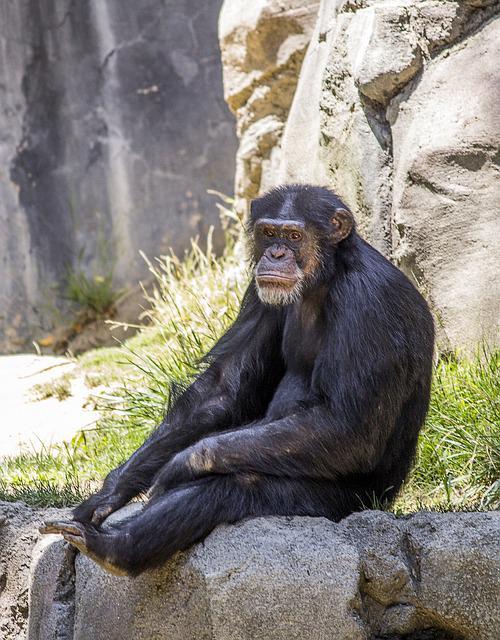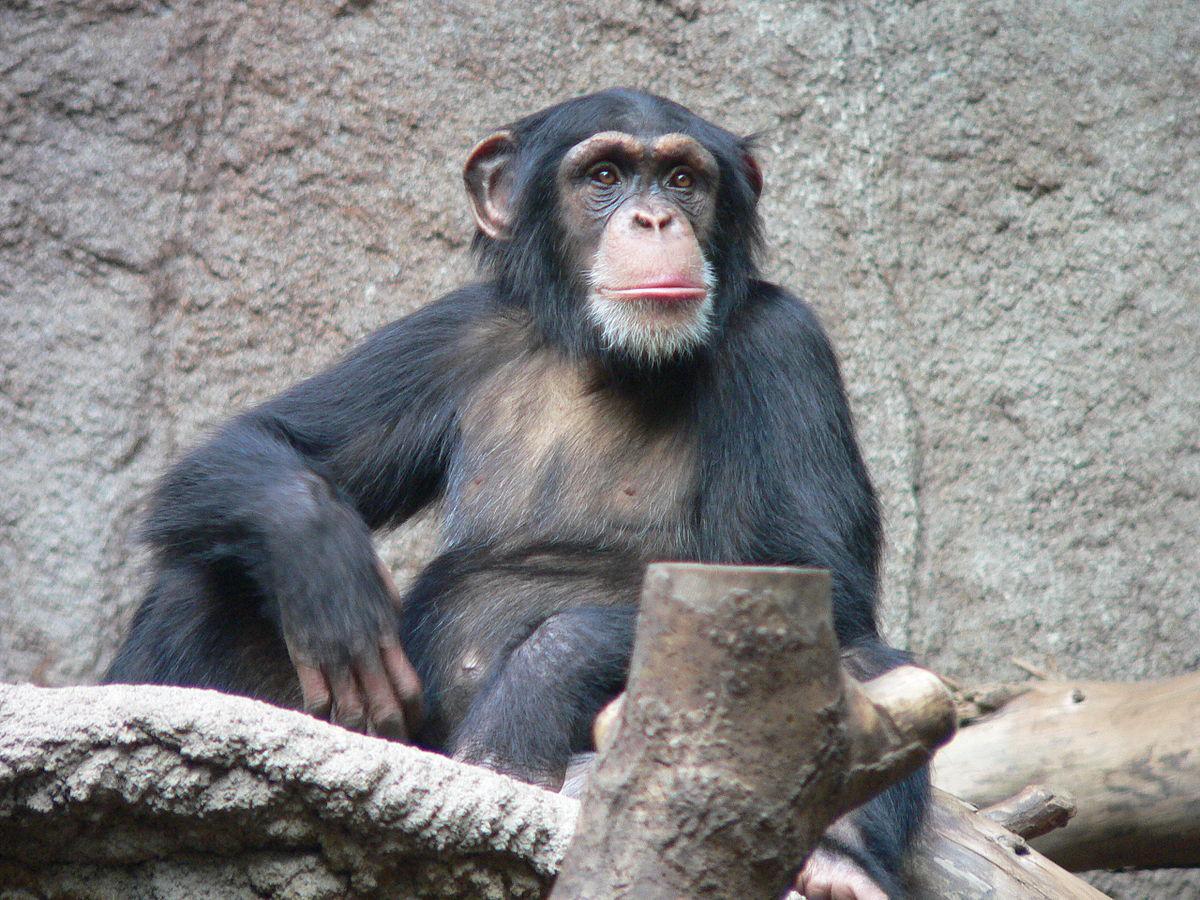The first image is the image on the left, the second image is the image on the right. Assess this claim about the two images: "An image shows at least one young chimp with an older chimp nearby.". Correct or not? Answer yes or no. No. The first image is the image on the left, the second image is the image on the right. For the images shown, is this caption "At least one of the images shows more than one chimpanzee." true? Answer yes or no. No. 